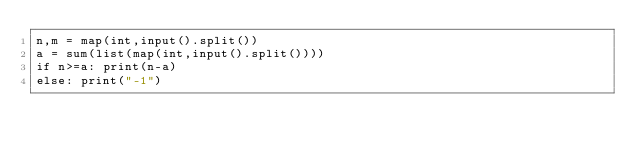Convert code to text. <code><loc_0><loc_0><loc_500><loc_500><_Python_>n,m = map(int,input().split())
a = sum(list(map(int,input().split())))
if n>=a: print(n-a)
else: print("-1")</code> 